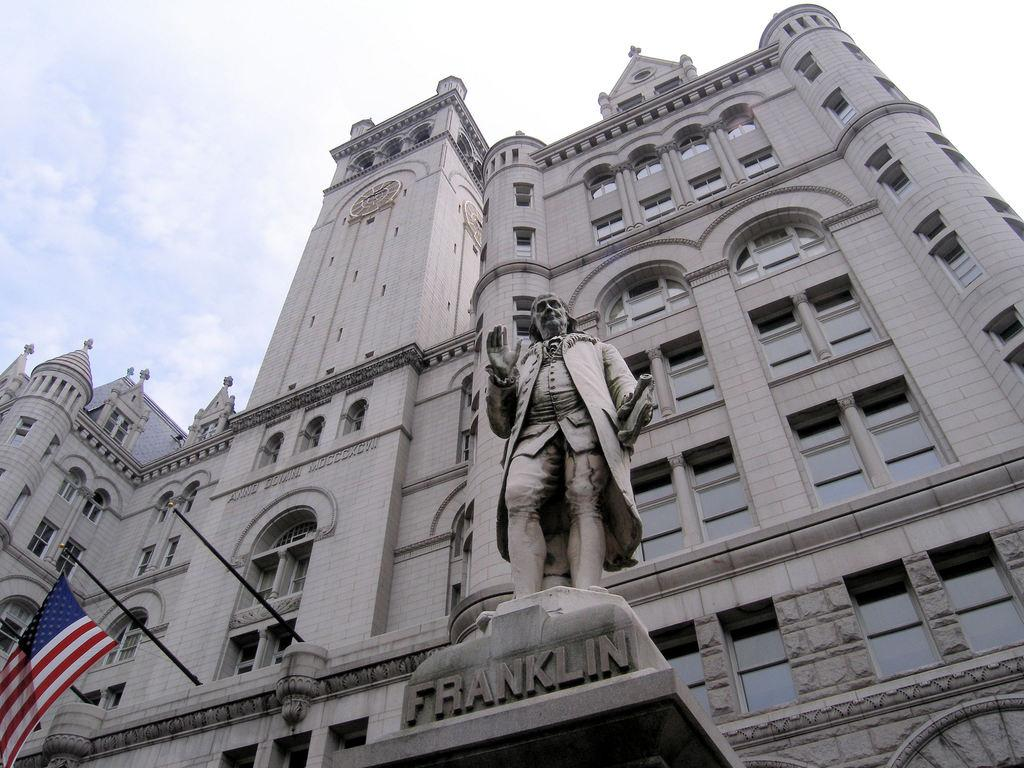What type of structure is present in the picture? There is a building in the picture. What feature can be observed on the building? The building has glass windows. Is there any other object or figure in the picture besides the building? Yes, there is a statue of a person in the picture. What is visible in the bottom left side of the picture? There is a flag on the bottom left side of the picture. What can be seen in the sky in the picture? There are clouds in the sky. What type of cloth is draped over the horse in the picture? There is no horse present in the picture, so there is no cloth draped over it. How does the tramp interact with the statue in the picture? There is no tramp present in the picture, so there is no interaction with the statue. 